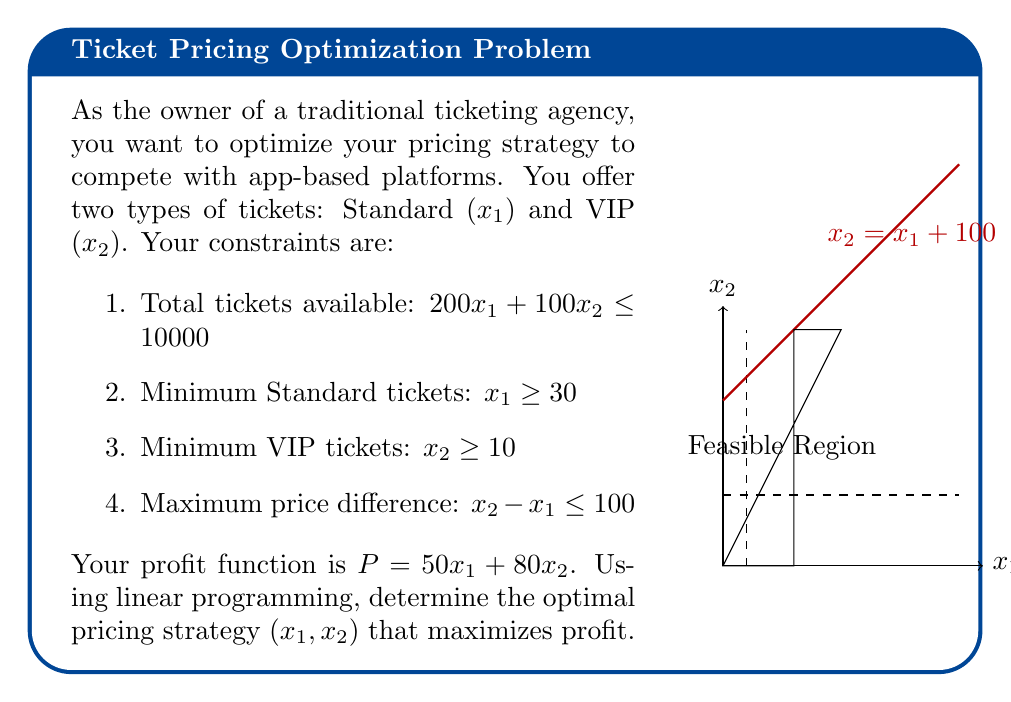Help me with this question. Let's solve this step-by-step using the simplex method:

1) First, we convert inequality constraints to equations by adding slack variables:
   $200x_1 + 100x_2 + s_1 = 10000$
   $x_1 - s_2 = 30$
   $x_2 - s_3 = 10$
   $x_2 - x_1 - s_4 = 100$

2) Our objective function: Maximize $P = 50x_1 + 80x_2$

3) Initial tableau:
   $$\begin{array}{c|cccccccc}
    & x_1 & x_2 & s_1 & s_2 & s_3 & s_4 & RHS \\
   \hline
   s_1 & 200 & 100 & 1 & 0 & 0 & 0 & 10000 \\
   s_2 & -1 & 0 & 0 & 1 & 0 & 0 & -30 \\
   s_3 & 0 & -1 & 0 & 0 & 1 & 0 & -10 \\
   s_4 & -1 & 1 & 0 & 0 & 0 & 1 & 100 \\
   \hline
   P & -50 & -80 & 0 & 0 & 0 & 0 & 0
   \end{array}$$

4) We choose the most negative coefficient in the objective row as our pivot column. Here, it's $x_2$ with -80.

5) We calculate the ratios for the pivot row:
   $10000/100 = 100$
   $-10/-1 = 10$
   $100/1 = 100$
   The smallest positive ratio is 10, so $s_3$ leaves the basis.

6) After pivoting, we get:
   $$\begin{array}{c|cccccccc}
    & x_1 & x_2 & s_1 & s_2 & s_3 & s_4 & RHS \\
   \hline
   s_1 & 200 & 0 & 1 & 0 & -100 & 0 & 9000 \\
   s_2 & -1 & 0 & 0 & 1 & 0 & 0 & -30 \\
   x_2 & 0 & 1 & 0 & 0 & -1 & 0 & 10 \\
   s_4 & -1 & 0 & 0 & 0 & 1 & 1 & 90 \\
   \hline
   P & -50 & 0 & 0 & 0 & 80 & 0 & 800
   \end{array}$$

7) We repeat the process, now pivoting on $x_1$. After this step, we reach the optimal solution:
   $$\begin{array}{c|cccccccc}
    & x_1 & x_2 & s_1 & s_2 & s_3 & s_4 & RHS \\
   \hline
   x_1 & 1 & 0 & 0 & -1 & 0 & 0 & 30 \\
   s_1 & 0 & 0 & 1 & 200 & -100 & 0 & 3000 \\
   x_2 & 0 & 1 & 0 & 0 & -1 & 0 & 10 \\
   s_4 & 0 & 0 & 0 & -1 & 1 & 1 & 60 \\
   \hline
   P & 0 & 0 & 0 & 50 & 80 & 0 & 2300
   \end{array}$$

8) From this tableau, we can read the optimal solution: $x_1 = 30$, $x_2 = 10$, with a maximum profit of 2300.
Answer: $(x_1, x_2) = (30, 10)$; Max Profit = $2300 